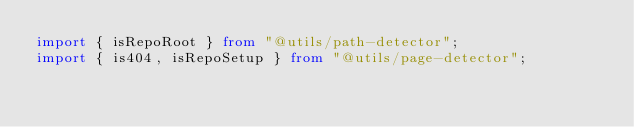Convert code to text. <code><loc_0><loc_0><loc_500><loc_500><_TypeScript_>import { isRepoRoot } from "@utils/path-detector";
import { is404, isRepoSetup } from "@utils/page-detector";</code> 